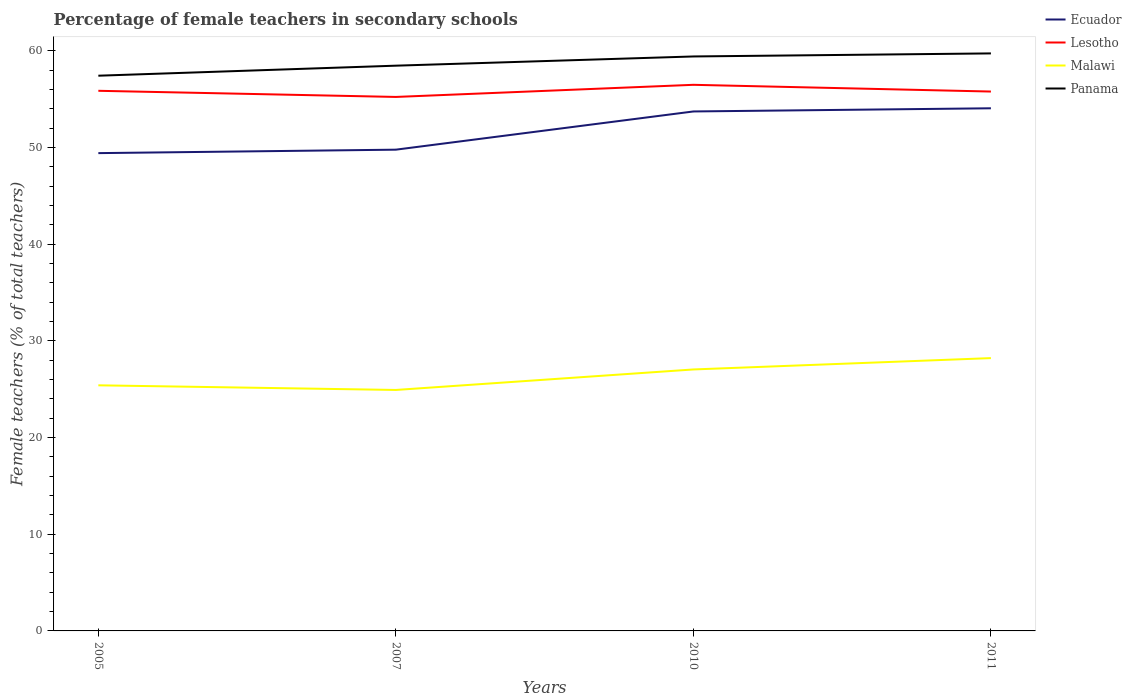Across all years, what is the maximum percentage of female teachers in Malawi?
Your answer should be very brief. 24.92. What is the total percentage of female teachers in Lesotho in the graph?
Keep it short and to the point. -0.56. What is the difference between the highest and the second highest percentage of female teachers in Ecuador?
Your response must be concise. 4.64. What is the difference between the highest and the lowest percentage of female teachers in Ecuador?
Make the answer very short. 2. Is the percentage of female teachers in Lesotho strictly greater than the percentage of female teachers in Panama over the years?
Provide a short and direct response. Yes. How many years are there in the graph?
Your answer should be compact. 4. Does the graph contain any zero values?
Give a very brief answer. No. Does the graph contain grids?
Offer a very short reply. No. What is the title of the graph?
Offer a terse response. Percentage of female teachers in secondary schools. Does "Vanuatu" appear as one of the legend labels in the graph?
Offer a very short reply. No. What is the label or title of the X-axis?
Keep it short and to the point. Years. What is the label or title of the Y-axis?
Your answer should be compact. Female teachers (% of total teachers). What is the Female teachers (% of total teachers) in Ecuador in 2005?
Give a very brief answer. 49.41. What is the Female teachers (% of total teachers) of Lesotho in 2005?
Offer a very short reply. 55.85. What is the Female teachers (% of total teachers) in Malawi in 2005?
Your answer should be compact. 25.4. What is the Female teachers (% of total teachers) in Panama in 2005?
Make the answer very short. 57.41. What is the Female teachers (% of total teachers) of Ecuador in 2007?
Offer a very short reply. 49.76. What is the Female teachers (% of total teachers) of Lesotho in 2007?
Keep it short and to the point. 55.22. What is the Female teachers (% of total teachers) of Malawi in 2007?
Ensure brevity in your answer.  24.92. What is the Female teachers (% of total teachers) in Panama in 2007?
Offer a very short reply. 58.45. What is the Female teachers (% of total teachers) of Ecuador in 2010?
Offer a terse response. 53.72. What is the Female teachers (% of total teachers) in Lesotho in 2010?
Provide a short and direct response. 56.47. What is the Female teachers (% of total teachers) in Malawi in 2010?
Provide a succinct answer. 27.04. What is the Female teachers (% of total teachers) in Panama in 2010?
Your response must be concise. 59.4. What is the Female teachers (% of total teachers) of Ecuador in 2011?
Make the answer very short. 54.04. What is the Female teachers (% of total teachers) of Lesotho in 2011?
Your answer should be compact. 55.77. What is the Female teachers (% of total teachers) of Malawi in 2011?
Ensure brevity in your answer.  28.21. What is the Female teachers (% of total teachers) of Panama in 2011?
Ensure brevity in your answer.  59.72. Across all years, what is the maximum Female teachers (% of total teachers) of Ecuador?
Offer a terse response. 54.04. Across all years, what is the maximum Female teachers (% of total teachers) in Lesotho?
Make the answer very short. 56.47. Across all years, what is the maximum Female teachers (% of total teachers) of Malawi?
Offer a very short reply. 28.21. Across all years, what is the maximum Female teachers (% of total teachers) in Panama?
Provide a short and direct response. 59.72. Across all years, what is the minimum Female teachers (% of total teachers) of Ecuador?
Keep it short and to the point. 49.41. Across all years, what is the minimum Female teachers (% of total teachers) of Lesotho?
Give a very brief answer. 55.22. Across all years, what is the minimum Female teachers (% of total teachers) of Malawi?
Provide a short and direct response. 24.92. Across all years, what is the minimum Female teachers (% of total teachers) of Panama?
Offer a terse response. 57.41. What is the total Female teachers (% of total teachers) in Ecuador in the graph?
Give a very brief answer. 206.93. What is the total Female teachers (% of total teachers) of Lesotho in the graph?
Keep it short and to the point. 223.31. What is the total Female teachers (% of total teachers) of Malawi in the graph?
Make the answer very short. 105.56. What is the total Female teachers (% of total teachers) in Panama in the graph?
Your answer should be compact. 234.98. What is the difference between the Female teachers (% of total teachers) in Ecuador in 2005 and that in 2007?
Provide a short and direct response. -0.36. What is the difference between the Female teachers (% of total teachers) of Lesotho in 2005 and that in 2007?
Keep it short and to the point. 0.63. What is the difference between the Female teachers (% of total teachers) in Malawi in 2005 and that in 2007?
Ensure brevity in your answer.  0.48. What is the difference between the Female teachers (% of total teachers) of Panama in 2005 and that in 2007?
Provide a succinct answer. -1.04. What is the difference between the Female teachers (% of total teachers) of Ecuador in 2005 and that in 2010?
Give a very brief answer. -4.31. What is the difference between the Female teachers (% of total teachers) in Lesotho in 2005 and that in 2010?
Provide a succinct answer. -0.62. What is the difference between the Female teachers (% of total teachers) of Malawi in 2005 and that in 2010?
Your response must be concise. -1.64. What is the difference between the Female teachers (% of total teachers) of Panama in 2005 and that in 2010?
Your response must be concise. -1.99. What is the difference between the Female teachers (% of total teachers) of Ecuador in 2005 and that in 2011?
Provide a succinct answer. -4.64. What is the difference between the Female teachers (% of total teachers) in Lesotho in 2005 and that in 2011?
Ensure brevity in your answer.  0.08. What is the difference between the Female teachers (% of total teachers) of Malawi in 2005 and that in 2011?
Make the answer very short. -2.81. What is the difference between the Female teachers (% of total teachers) in Panama in 2005 and that in 2011?
Give a very brief answer. -2.31. What is the difference between the Female teachers (% of total teachers) of Ecuador in 2007 and that in 2010?
Offer a terse response. -3.95. What is the difference between the Female teachers (% of total teachers) in Lesotho in 2007 and that in 2010?
Your answer should be very brief. -1.25. What is the difference between the Female teachers (% of total teachers) in Malawi in 2007 and that in 2010?
Provide a succinct answer. -2.12. What is the difference between the Female teachers (% of total teachers) of Panama in 2007 and that in 2010?
Give a very brief answer. -0.95. What is the difference between the Female teachers (% of total teachers) of Ecuador in 2007 and that in 2011?
Give a very brief answer. -4.28. What is the difference between the Female teachers (% of total teachers) of Lesotho in 2007 and that in 2011?
Give a very brief answer. -0.56. What is the difference between the Female teachers (% of total teachers) in Malawi in 2007 and that in 2011?
Keep it short and to the point. -3.29. What is the difference between the Female teachers (% of total teachers) of Panama in 2007 and that in 2011?
Your answer should be compact. -1.27. What is the difference between the Female teachers (% of total teachers) of Ecuador in 2010 and that in 2011?
Offer a terse response. -0.33. What is the difference between the Female teachers (% of total teachers) in Lesotho in 2010 and that in 2011?
Make the answer very short. 0.7. What is the difference between the Female teachers (% of total teachers) in Malawi in 2010 and that in 2011?
Your response must be concise. -1.17. What is the difference between the Female teachers (% of total teachers) in Panama in 2010 and that in 2011?
Offer a very short reply. -0.32. What is the difference between the Female teachers (% of total teachers) in Ecuador in 2005 and the Female teachers (% of total teachers) in Lesotho in 2007?
Offer a very short reply. -5.81. What is the difference between the Female teachers (% of total teachers) of Ecuador in 2005 and the Female teachers (% of total teachers) of Malawi in 2007?
Offer a terse response. 24.49. What is the difference between the Female teachers (% of total teachers) in Ecuador in 2005 and the Female teachers (% of total teachers) in Panama in 2007?
Give a very brief answer. -9.04. What is the difference between the Female teachers (% of total teachers) of Lesotho in 2005 and the Female teachers (% of total teachers) of Malawi in 2007?
Make the answer very short. 30.93. What is the difference between the Female teachers (% of total teachers) in Lesotho in 2005 and the Female teachers (% of total teachers) in Panama in 2007?
Your answer should be very brief. -2.6. What is the difference between the Female teachers (% of total teachers) of Malawi in 2005 and the Female teachers (% of total teachers) of Panama in 2007?
Keep it short and to the point. -33.05. What is the difference between the Female teachers (% of total teachers) in Ecuador in 2005 and the Female teachers (% of total teachers) in Lesotho in 2010?
Keep it short and to the point. -7.06. What is the difference between the Female teachers (% of total teachers) of Ecuador in 2005 and the Female teachers (% of total teachers) of Malawi in 2010?
Your response must be concise. 22.37. What is the difference between the Female teachers (% of total teachers) in Ecuador in 2005 and the Female teachers (% of total teachers) in Panama in 2010?
Your response must be concise. -10. What is the difference between the Female teachers (% of total teachers) of Lesotho in 2005 and the Female teachers (% of total teachers) of Malawi in 2010?
Your answer should be very brief. 28.81. What is the difference between the Female teachers (% of total teachers) of Lesotho in 2005 and the Female teachers (% of total teachers) of Panama in 2010?
Ensure brevity in your answer.  -3.55. What is the difference between the Female teachers (% of total teachers) in Malawi in 2005 and the Female teachers (% of total teachers) in Panama in 2010?
Keep it short and to the point. -34.01. What is the difference between the Female teachers (% of total teachers) in Ecuador in 2005 and the Female teachers (% of total teachers) in Lesotho in 2011?
Keep it short and to the point. -6.37. What is the difference between the Female teachers (% of total teachers) in Ecuador in 2005 and the Female teachers (% of total teachers) in Malawi in 2011?
Your answer should be very brief. 21.2. What is the difference between the Female teachers (% of total teachers) in Ecuador in 2005 and the Female teachers (% of total teachers) in Panama in 2011?
Provide a succinct answer. -10.31. What is the difference between the Female teachers (% of total teachers) in Lesotho in 2005 and the Female teachers (% of total teachers) in Malawi in 2011?
Keep it short and to the point. 27.64. What is the difference between the Female teachers (% of total teachers) in Lesotho in 2005 and the Female teachers (% of total teachers) in Panama in 2011?
Offer a terse response. -3.87. What is the difference between the Female teachers (% of total teachers) in Malawi in 2005 and the Female teachers (% of total teachers) in Panama in 2011?
Your answer should be compact. -34.32. What is the difference between the Female teachers (% of total teachers) of Ecuador in 2007 and the Female teachers (% of total teachers) of Lesotho in 2010?
Provide a short and direct response. -6.71. What is the difference between the Female teachers (% of total teachers) in Ecuador in 2007 and the Female teachers (% of total teachers) in Malawi in 2010?
Provide a succinct answer. 22.73. What is the difference between the Female teachers (% of total teachers) of Ecuador in 2007 and the Female teachers (% of total teachers) of Panama in 2010?
Make the answer very short. -9.64. What is the difference between the Female teachers (% of total teachers) of Lesotho in 2007 and the Female teachers (% of total teachers) of Malawi in 2010?
Keep it short and to the point. 28.18. What is the difference between the Female teachers (% of total teachers) in Lesotho in 2007 and the Female teachers (% of total teachers) in Panama in 2010?
Give a very brief answer. -4.18. What is the difference between the Female teachers (% of total teachers) of Malawi in 2007 and the Female teachers (% of total teachers) of Panama in 2010?
Offer a terse response. -34.48. What is the difference between the Female teachers (% of total teachers) in Ecuador in 2007 and the Female teachers (% of total teachers) in Lesotho in 2011?
Your response must be concise. -6.01. What is the difference between the Female teachers (% of total teachers) of Ecuador in 2007 and the Female teachers (% of total teachers) of Malawi in 2011?
Your answer should be very brief. 21.55. What is the difference between the Female teachers (% of total teachers) in Ecuador in 2007 and the Female teachers (% of total teachers) in Panama in 2011?
Keep it short and to the point. -9.95. What is the difference between the Female teachers (% of total teachers) in Lesotho in 2007 and the Female teachers (% of total teachers) in Malawi in 2011?
Your answer should be compact. 27.01. What is the difference between the Female teachers (% of total teachers) of Lesotho in 2007 and the Female teachers (% of total teachers) of Panama in 2011?
Make the answer very short. -4.5. What is the difference between the Female teachers (% of total teachers) of Malawi in 2007 and the Female teachers (% of total teachers) of Panama in 2011?
Provide a succinct answer. -34.8. What is the difference between the Female teachers (% of total teachers) of Ecuador in 2010 and the Female teachers (% of total teachers) of Lesotho in 2011?
Ensure brevity in your answer.  -2.06. What is the difference between the Female teachers (% of total teachers) of Ecuador in 2010 and the Female teachers (% of total teachers) of Malawi in 2011?
Offer a very short reply. 25.5. What is the difference between the Female teachers (% of total teachers) of Ecuador in 2010 and the Female teachers (% of total teachers) of Panama in 2011?
Give a very brief answer. -6. What is the difference between the Female teachers (% of total teachers) of Lesotho in 2010 and the Female teachers (% of total teachers) of Malawi in 2011?
Offer a terse response. 28.26. What is the difference between the Female teachers (% of total teachers) of Lesotho in 2010 and the Female teachers (% of total teachers) of Panama in 2011?
Your answer should be very brief. -3.25. What is the difference between the Female teachers (% of total teachers) in Malawi in 2010 and the Female teachers (% of total teachers) in Panama in 2011?
Provide a succinct answer. -32.68. What is the average Female teachers (% of total teachers) in Ecuador per year?
Provide a short and direct response. 51.73. What is the average Female teachers (% of total teachers) in Lesotho per year?
Your answer should be very brief. 55.83. What is the average Female teachers (% of total teachers) of Malawi per year?
Make the answer very short. 26.39. What is the average Female teachers (% of total teachers) of Panama per year?
Provide a succinct answer. 58.75. In the year 2005, what is the difference between the Female teachers (% of total teachers) of Ecuador and Female teachers (% of total teachers) of Lesotho?
Provide a succinct answer. -6.44. In the year 2005, what is the difference between the Female teachers (% of total teachers) in Ecuador and Female teachers (% of total teachers) in Malawi?
Provide a short and direct response. 24.01. In the year 2005, what is the difference between the Female teachers (% of total teachers) of Ecuador and Female teachers (% of total teachers) of Panama?
Offer a terse response. -8.01. In the year 2005, what is the difference between the Female teachers (% of total teachers) in Lesotho and Female teachers (% of total teachers) in Malawi?
Offer a terse response. 30.45. In the year 2005, what is the difference between the Female teachers (% of total teachers) of Lesotho and Female teachers (% of total teachers) of Panama?
Offer a very short reply. -1.56. In the year 2005, what is the difference between the Female teachers (% of total teachers) of Malawi and Female teachers (% of total teachers) of Panama?
Ensure brevity in your answer.  -32.02. In the year 2007, what is the difference between the Female teachers (% of total teachers) of Ecuador and Female teachers (% of total teachers) of Lesotho?
Give a very brief answer. -5.45. In the year 2007, what is the difference between the Female teachers (% of total teachers) of Ecuador and Female teachers (% of total teachers) of Malawi?
Your answer should be compact. 24.85. In the year 2007, what is the difference between the Female teachers (% of total teachers) in Ecuador and Female teachers (% of total teachers) in Panama?
Provide a short and direct response. -8.69. In the year 2007, what is the difference between the Female teachers (% of total teachers) of Lesotho and Female teachers (% of total teachers) of Malawi?
Offer a terse response. 30.3. In the year 2007, what is the difference between the Female teachers (% of total teachers) of Lesotho and Female teachers (% of total teachers) of Panama?
Make the answer very short. -3.23. In the year 2007, what is the difference between the Female teachers (% of total teachers) of Malawi and Female teachers (% of total teachers) of Panama?
Give a very brief answer. -33.53. In the year 2010, what is the difference between the Female teachers (% of total teachers) of Ecuador and Female teachers (% of total teachers) of Lesotho?
Keep it short and to the point. -2.75. In the year 2010, what is the difference between the Female teachers (% of total teachers) of Ecuador and Female teachers (% of total teachers) of Malawi?
Ensure brevity in your answer.  26.68. In the year 2010, what is the difference between the Female teachers (% of total teachers) in Ecuador and Female teachers (% of total teachers) in Panama?
Provide a succinct answer. -5.69. In the year 2010, what is the difference between the Female teachers (% of total teachers) of Lesotho and Female teachers (% of total teachers) of Malawi?
Your response must be concise. 29.43. In the year 2010, what is the difference between the Female teachers (% of total teachers) in Lesotho and Female teachers (% of total teachers) in Panama?
Provide a short and direct response. -2.93. In the year 2010, what is the difference between the Female teachers (% of total teachers) in Malawi and Female teachers (% of total teachers) in Panama?
Your answer should be very brief. -32.36. In the year 2011, what is the difference between the Female teachers (% of total teachers) in Ecuador and Female teachers (% of total teachers) in Lesotho?
Your answer should be very brief. -1.73. In the year 2011, what is the difference between the Female teachers (% of total teachers) in Ecuador and Female teachers (% of total teachers) in Malawi?
Make the answer very short. 25.83. In the year 2011, what is the difference between the Female teachers (% of total teachers) in Ecuador and Female teachers (% of total teachers) in Panama?
Provide a short and direct response. -5.67. In the year 2011, what is the difference between the Female teachers (% of total teachers) in Lesotho and Female teachers (% of total teachers) in Malawi?
Your answer should be very brief. 27.56. In the year 2011, what is the difference between the Female teachers (% of total teachers) of Lesotho and Female teachers (% of total teachers) of Panama?
Give a very brief answer. -3.94. In the year 2011, what is the difference between the Female teachers (% of total teachers) in Malawi and Female teachers (% of total teachers) in Panama?
Give a very brief answer. -31.51. What is the ratio of the Female teachers (% of total teachers) of Ecuador in 2005 to that in 2007?
Your response must be concise. 0.99. What is the ratio of the Female teachers (% of total teachers) in Lesotho in 2005 to that in 2007?
Make the answer very short. 1.01. What is the ratio of the Female teachers (% of total teachers) in Malawi in 2005 to that in 2007?
Offer a terse response. 1.02. What is the ratio of the Female teachers (% of total teachers) in Panama in 2005 to that in 2007?
Offer a terse response. 0.98. What is the ratio of the Female teachers (% of total teachers) of Ecuador in 2005 to that in 2010?
Your answer should be very brief. 0.92. What is the ratio of the Female teachers (% of total teachers) in Malawi in 2005 to that in 2010?
Ensure brevity in your answer.  0.94. What is the ratio of the Female teachers (% of total teachers) in Panama in 2005 to that in 2010?
Offer a very short reply. 0.97. What is the ratio of the Female teachers (% of total teachers) in Ecuador in 2005 to that in 2011?
Offer a terse response. 0.91. What is the ratio of the Female teachers (% of total teachers) in Lesotho in 2005 to that in 2011?
Your answer should be very brief. 1. What is the ratio of the Female teachers (% of total teachers) of Malawi in 2005 to that in 2011?
Your response must be concise. 0.9. What is the ratio of the Female teachers (% of total teachers) of Panama in 2005 to that in 2011?
Offer a very short reply. 0.96. What is the ratio of the Female teachers (% of total teachers) in Ecuador in 2007 to that in 2010?
Make the answer very short. 0.93. What is the ratio of the Female teachers (% of total teachers) in Lesotho in 2007 to that in 2010?
Ensure brevity in your answer.  0.98. What is the ratio of the Female teachers (% of total teachers) in Malawi in 2007 to that in 2010?
Offer a very short reply. 0.92. What is the ratio of the Female teachers (% of total teachers) of Panama in 2007 to that in 2010?
Ensure brevity in your answer.  0.98. What is the ratio of the Female teachers (% of total teachers) of Ecuador in 2007 to that in 2011?
Offer a very short reply. 0.92. What is the ratio of the Female teachers (% of total teachers) in Malawi in 2007 to that in 2011?
Offer a terse response. 0.88. What is the ratio of the Female teachers (% of total teachers) in Panama in 2007 to that in 2011?
Your answer should be compact. 0.98. What is the ratio of the Female teachers (% of total teachers) of Ecuador in 2010 to that in 2011?
Offer a very short reply. 0.99. What is the ratio of the Female teachers (% of total teachers) in Lesotho in 2010 to that in 2011?
Your answer should be very brief. 1.01. What is the ratio of the Female teachers (% of total teachers) in Malawi in 2010 to that in 2011?
Make the answer very short. 0.96. What is the ratio of the Female teachers (% of total teachers) in Panama in 2010 to that in 2011?
Make the answer very short. 0.99. What is the difference between the highest and the second highest Female teachers (% of total teachers) of Ecuador?
Offer a terse response. 0.33. What is the difference between the highest and the second highest Female teachers (% of total teachers) in Lesotho?
Keep it short and to the point. 0.62. What is the difference between the highest and the second highest Female teachers (% of total teachers) in Malawi?
Your answer should be very brief. 1.17. What is the difference between the highest and the second highest Female teachers (% of total teachers) in Panama?
Keep it short and to the point. 0.32. What is the difference between the highest and the lowest Female teachers (% of total teachers) of Ecuador?
Your answer should be compact. 4.64. What is the difference between the highest and the lowest Female teachers (% of total teachers) of Lesotho?
Ensure brevity in your answer.  1.25. What is the difference between the highest and the lowest Female teachers (% of total teachers) of Malawi?
Give a very brief answer. 3.29. What is the difference between the highest and the lowest Female teachers (% of total teachers) of Panama?
Offer a very short reply. 2.31. 